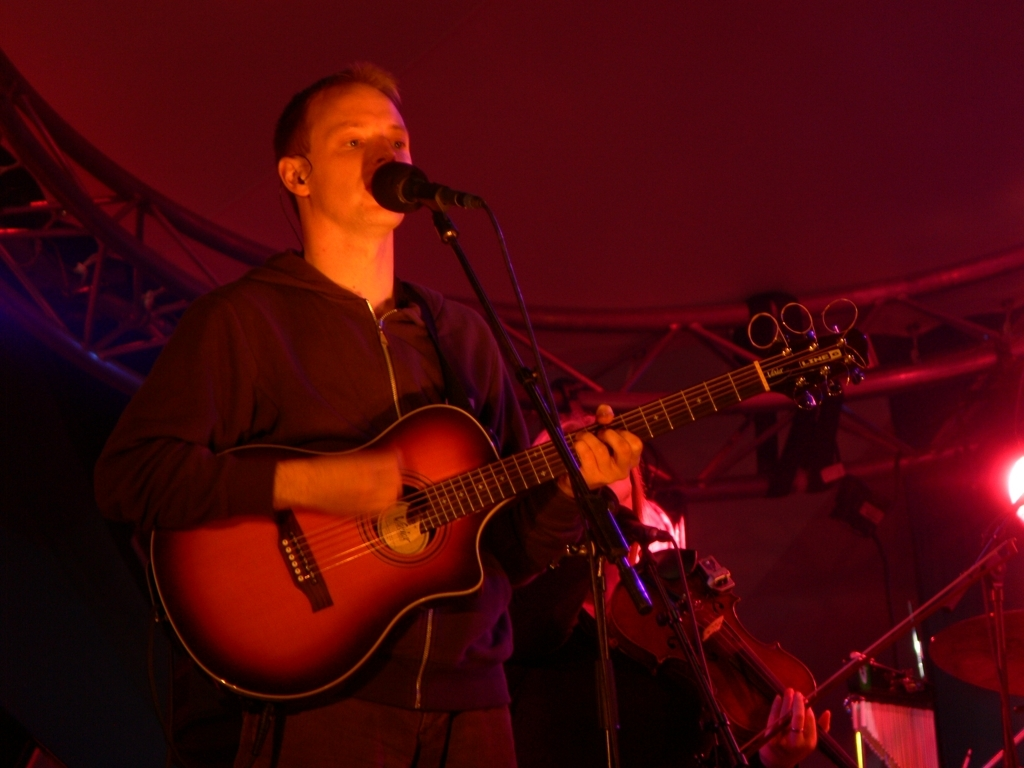Can you describe the atmosphere of the venue where the photo was taken? The venue appears to have an intimate yet vibrant atmosphere, as indicated by the warm, ambient lighting and the structure of the stage. The setting seems to evoke a cozy ambience, likely enhancing the connection between the artist and the audience during a live performance. 